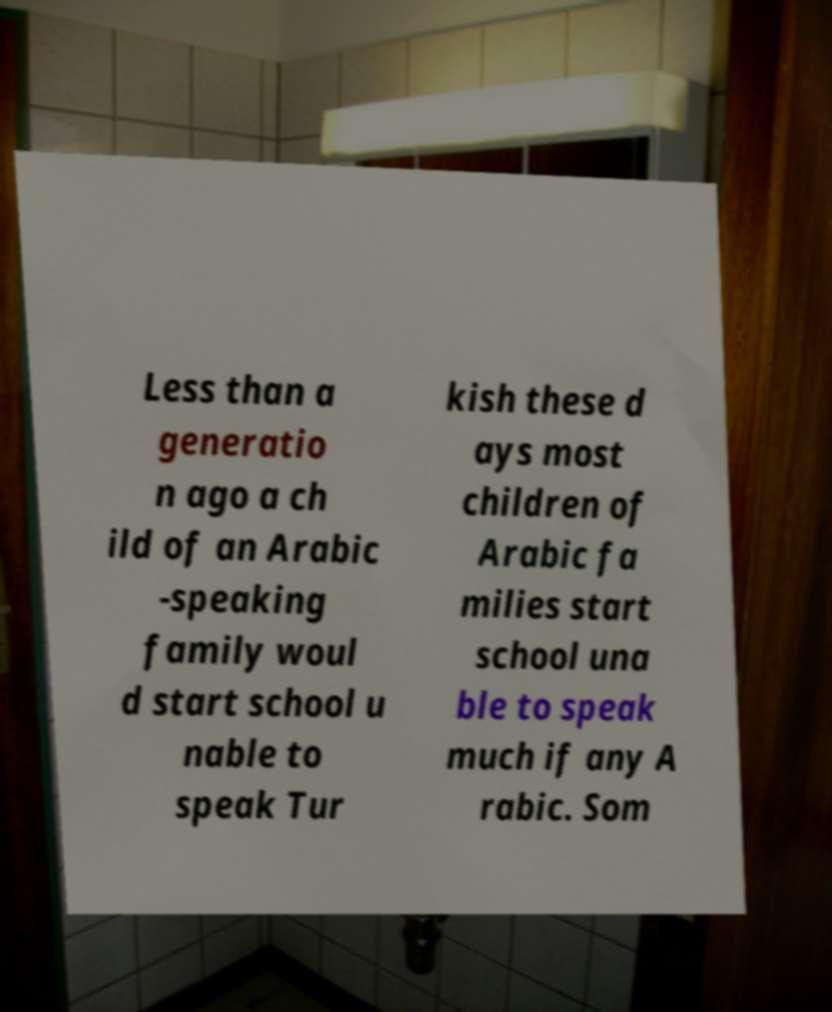Please read and relay the text visible in this image. What does it say? Less than a generatio n ago a ch ild of an Arabic -speaking family woul d start school u nable to speak Tur kish these d ays most children of Arabic fa milies start school una ble to speak much if any A rabic. Som 